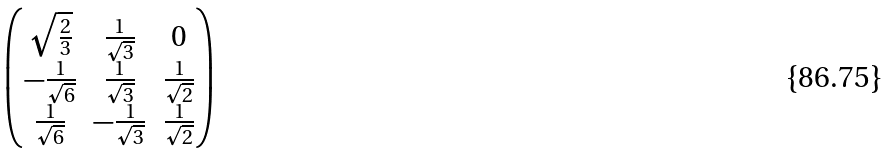<formula> <loc_0><loc_0><loc_500><loc_500>\begin{pmatrix} \sqrt { \frac { 2 } { 3 } } & \frac { 1 } { \sqrt { 3 } } & 0 \\ - \frac { 1 } { \sqrt { 6 } } & \frac { 1 } { \sqrt { 3 } } & \frac { 1 } { \sqrt { 2 } } \\ \frac { 1 } { \sqrt { 6 } } & - \frac { 1 } { \sqrt { 3 } } & \frac { 1 } { \sqrt { 2 } } \\ \end{pmatrix}</formula> 